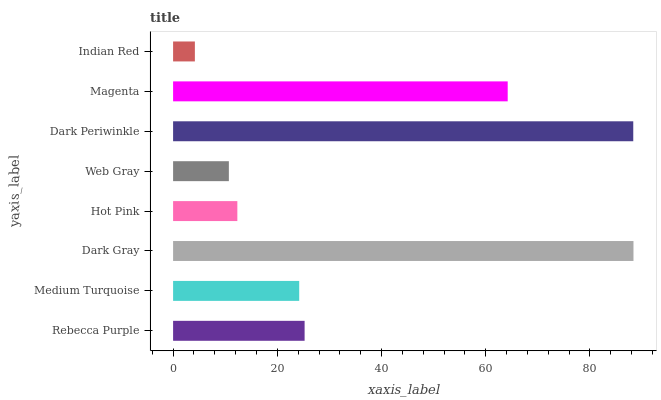Is Indian Red the minimum?
Answer yes or no. Yes. Is Dark Gray the maximum?
Answer yes or no. Yes. Is Medium Turquoise the minimum?
Answer yes or no. No. Is Medium Turquoise the maximum?
Answer yes or no. No. Is Rebecca Purple greater than Medium Turquoise?
Answer yes or no. Yes. Is Medium Turquoise less than Rebecca Purple?
Answer yes or no. Yes. Is Medium Turquoise greater than Rebecca Purple?
Answer yes or no. No. Is Rebecca Purple less than Medium Turquoise?
Answer yes or no. No. Is Rebecca Purple the high median?
Answer yes or no. Yes. Is Medium Turquoise the low median?
Answer yes or no. Yes. Is Dark Periwinkle the high median?
Answer yes or no. No. Is Rebecca Purple the low median?
Answer yes or no. No. 